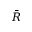<formula> <loc_0><loc_0><loc_500><loc_500>\bar { R }</formula> 